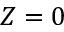<formula> <loc_0><loc_0><loc_500><loc_500>Z = 0</formula> 